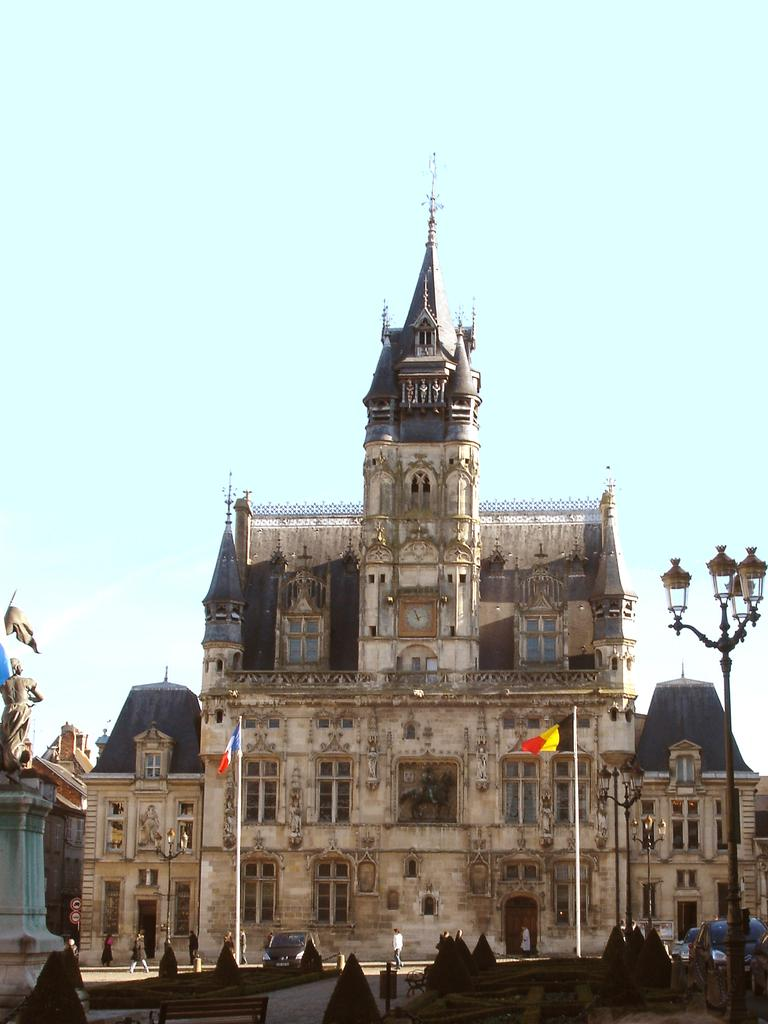What type of structures can be seen in the image? There are buildings in the image. What additional elements are present in the image? There are flags, a statue, streetlights, and people on the ground in the image. What can be seen in the sky in the background of the image? The sky is visible in the background of the image. What type of dress is the boy wearing in the image? There is no boy present in the image, so it is not possible to determine what type of dress he might be wearing. 